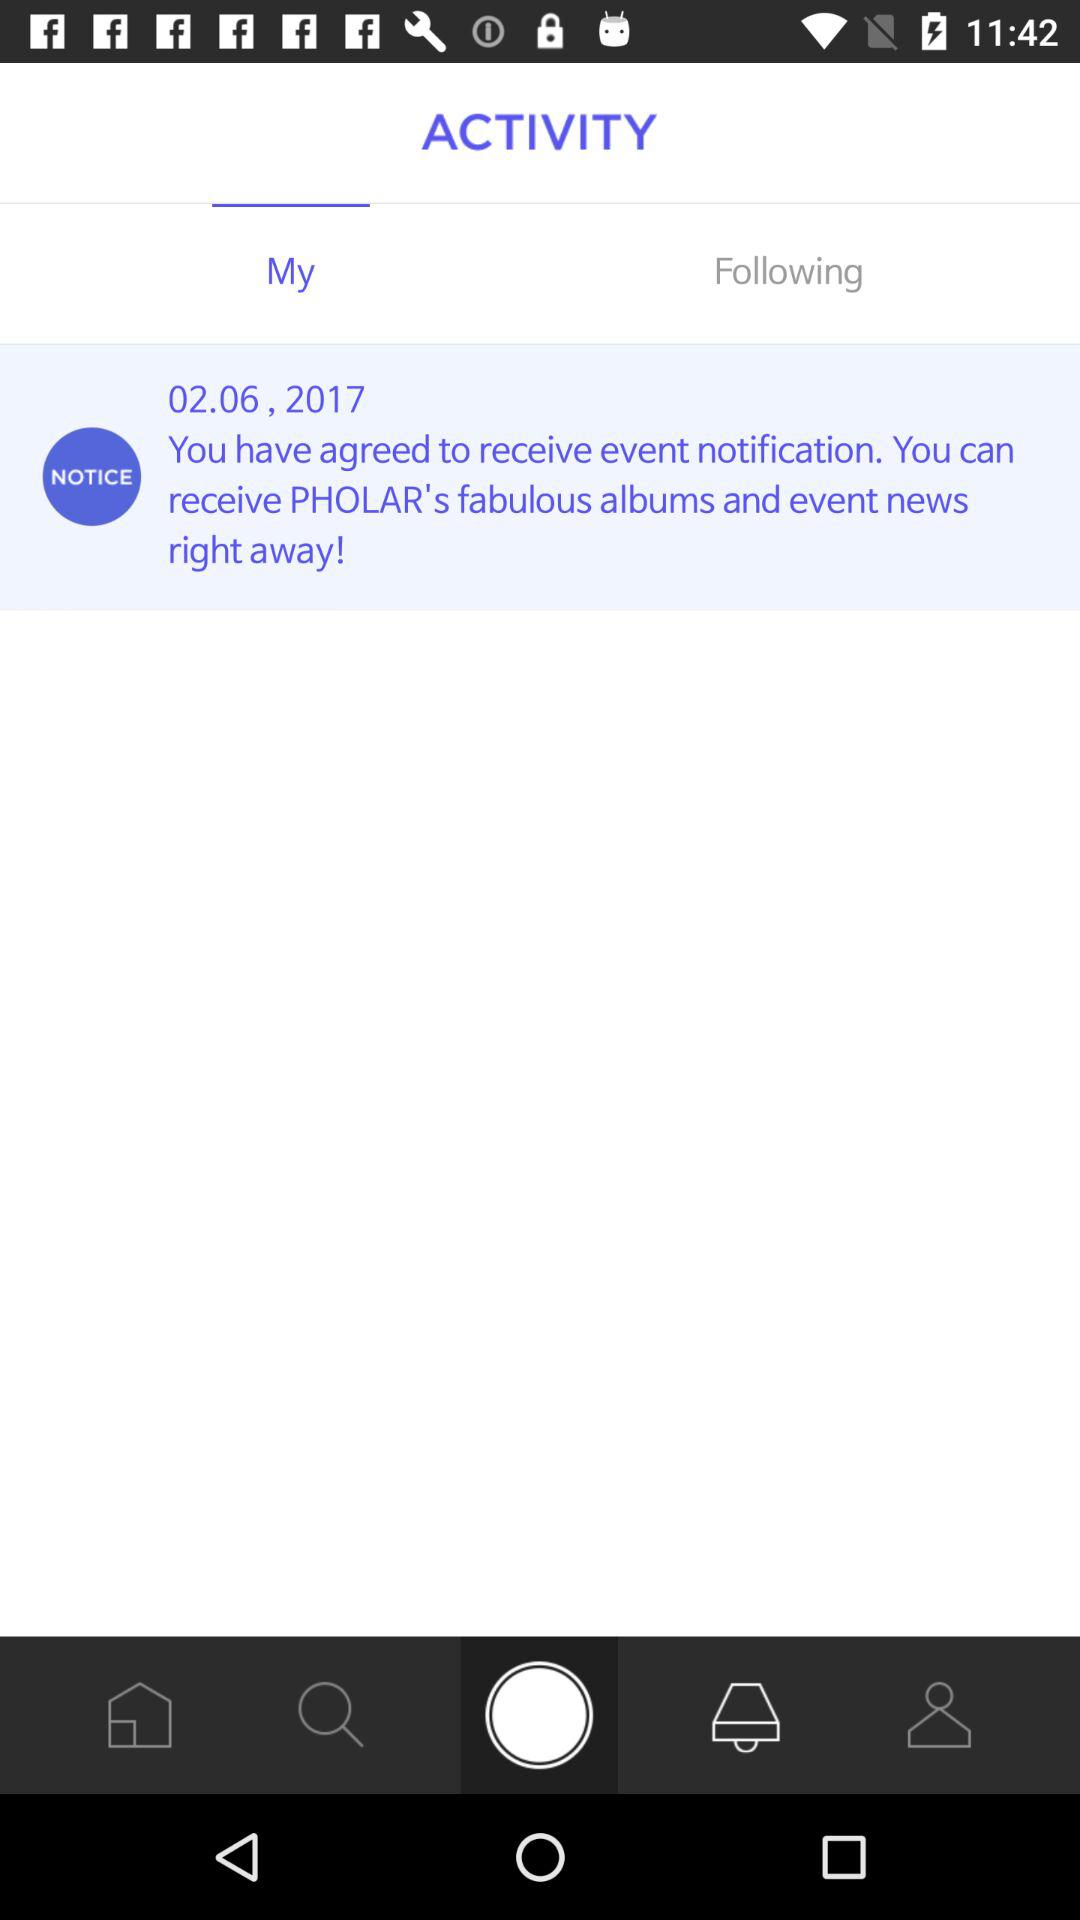Which tab is selected? The selected tab is "My". 